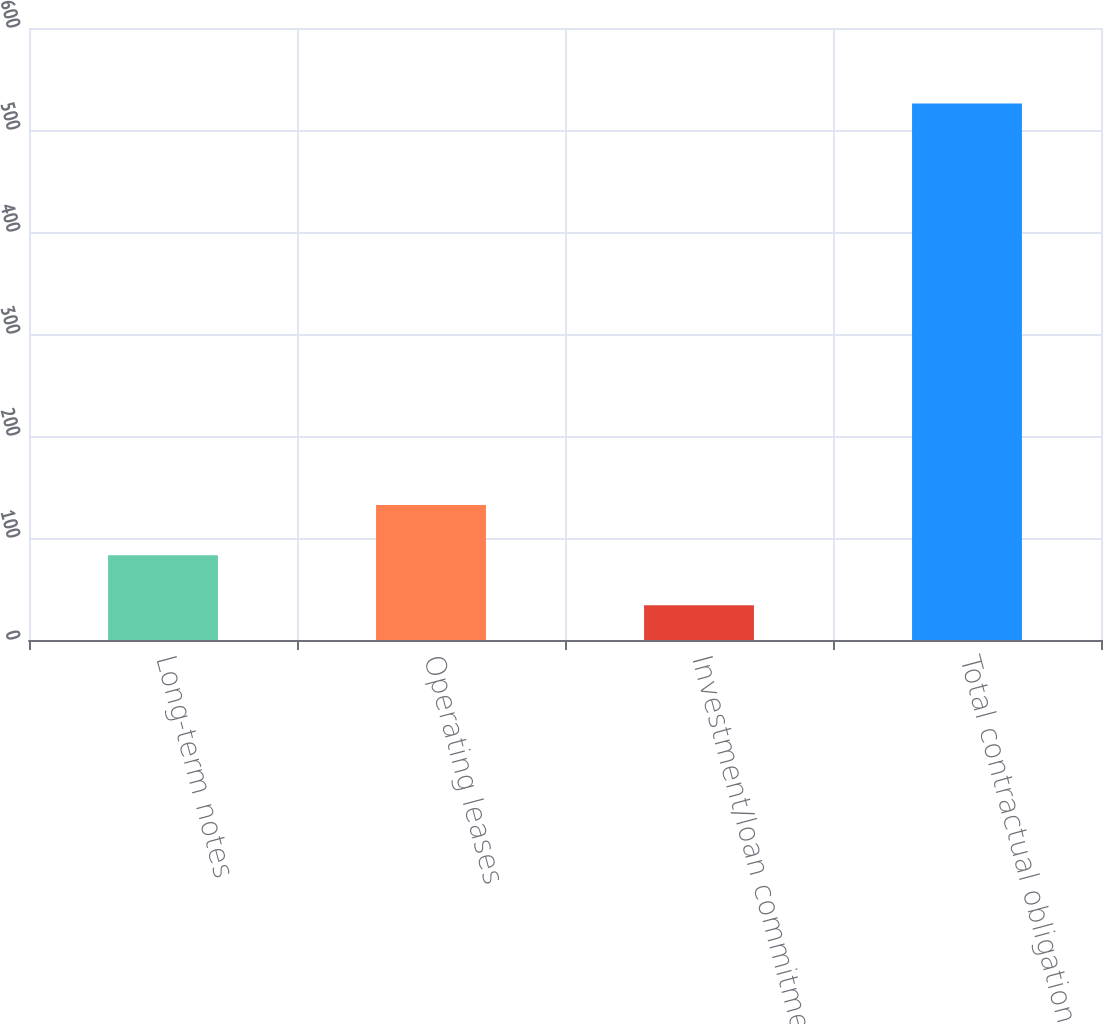Convert chart to OTSL. <chart><loc_0><loc_0><loc_500><loc_500><bar_chart><fcel>Long-term notes<fcel>Operating leases<fcel>Investment/loan commitments<fcel>Total contractual obligations<nl><fcel>83.2<fcel>132.4<fcel>34<fcel>526<nl></chart> 